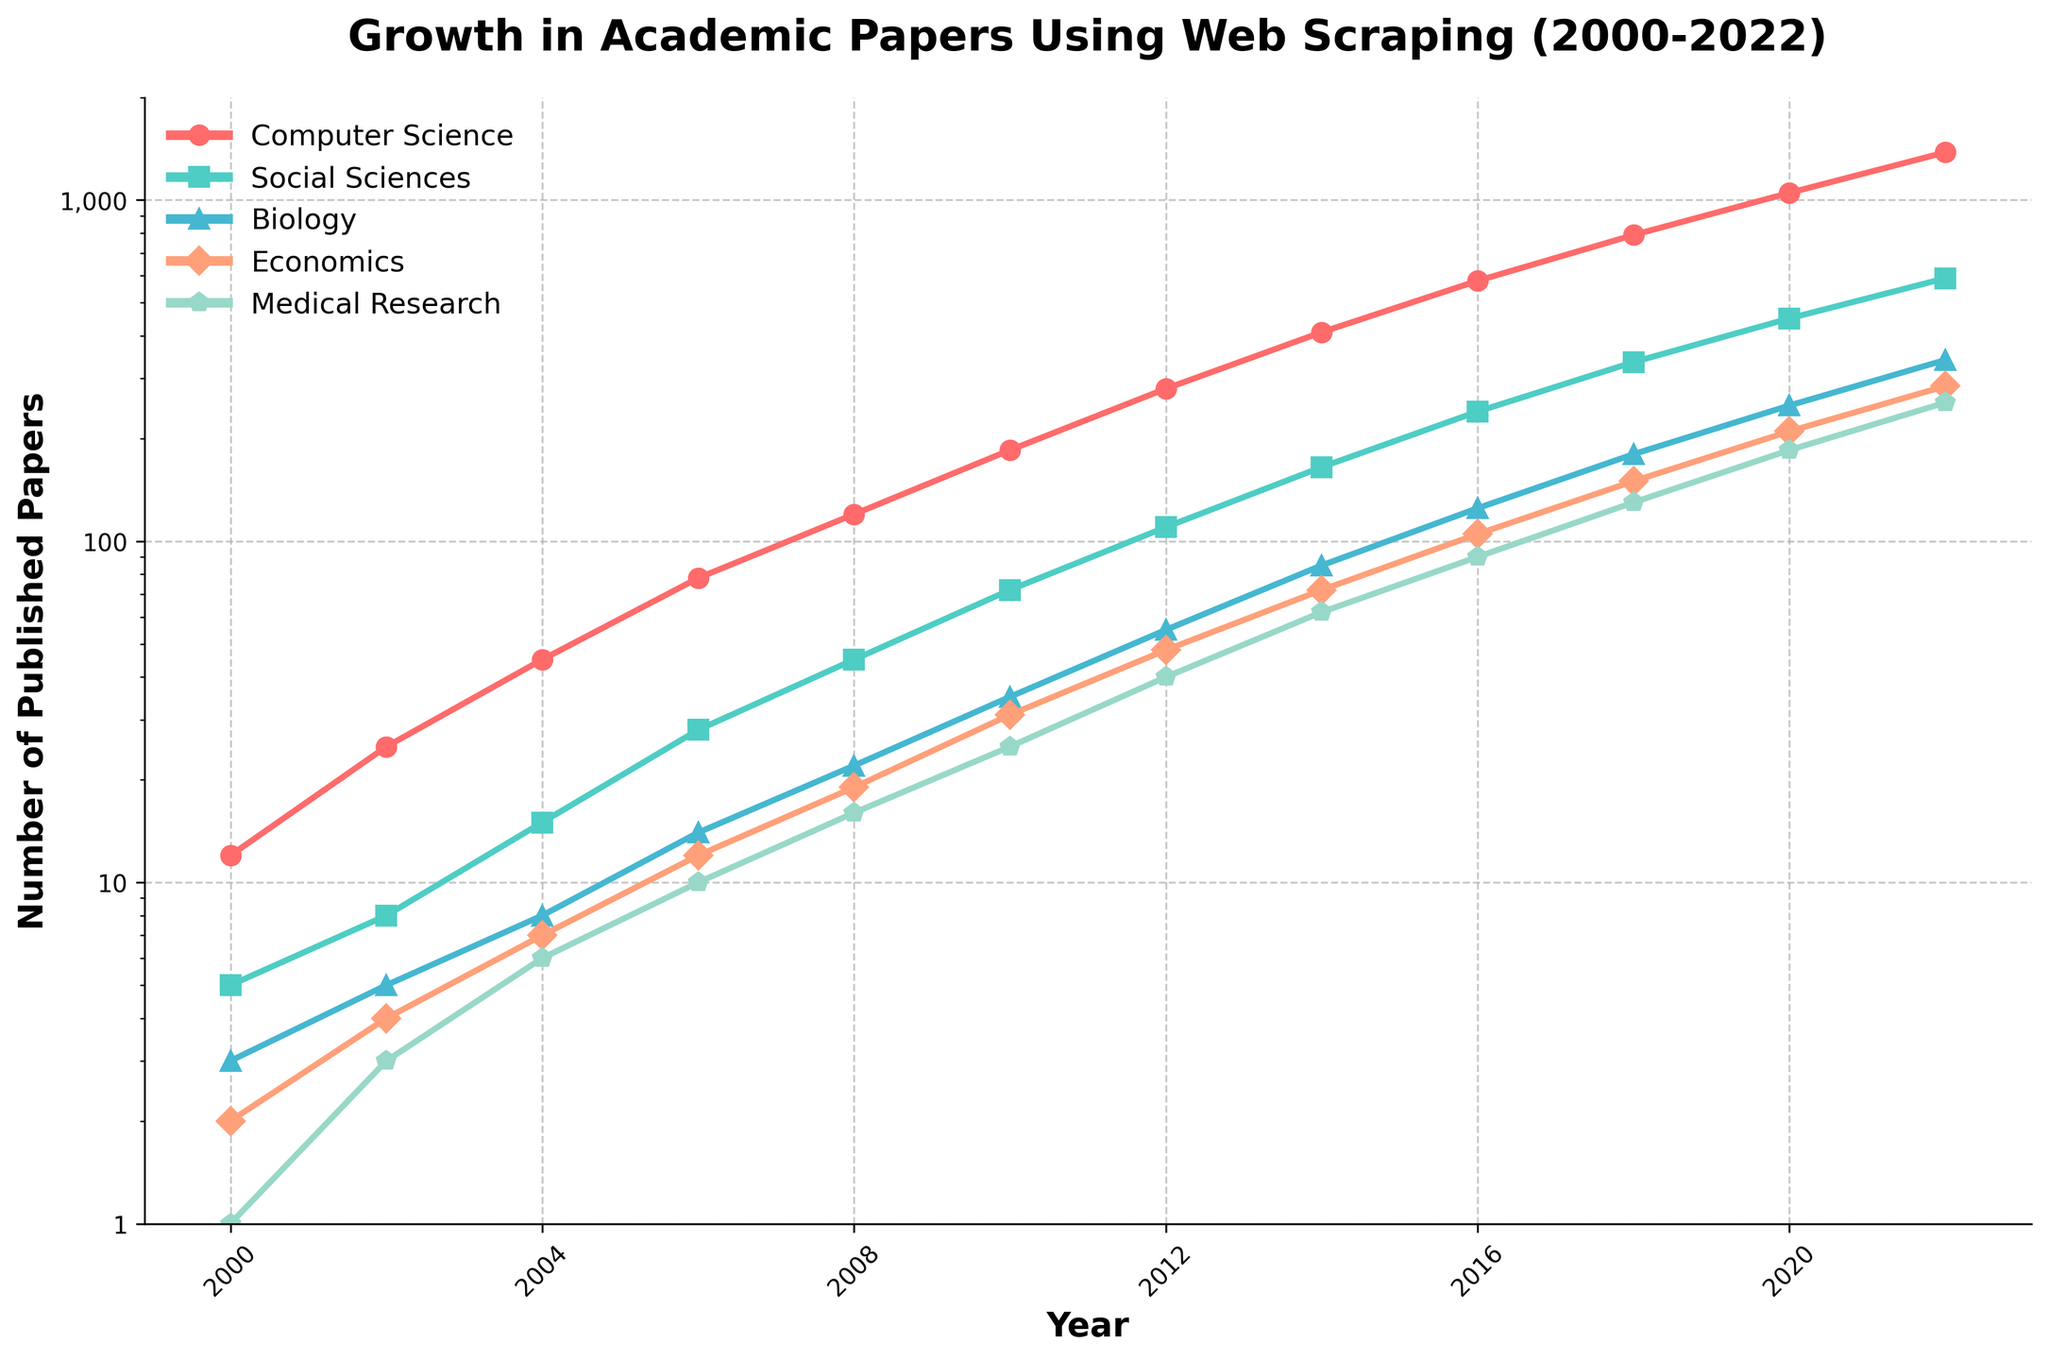What is the overall trend in the number of published papers utilizing web scraping techniques across various research fields since 2000? Starting from 2000, all fields show a consistent upward trend. Computer Science has the steepest increase, followed by Social Sciences, Biology, Economics, and Medical Research.
Answer: Steady increase Which research field had the highest number of papers in 2022, and how many were there? In 2022, Computer Science had the highest number of published papers at 1380.
Answer: Computer Science, 1380 Compare the growth in the number of published papers between Computer Science and Social Sciences from 2000 to 2010. In 2000, Computer Science had 12 papers, and Social Sciences had 5. By 2010, Computer Science had 185 papers, and Social Sciences had 72. The growth for Computer Science is 185 - 12 = 173 papers, and for Social Sciences, it is 72 - 5 = 67 papers.
Answer: Computer Science: 173, Social Sciences: 67 What is the total number of papers published in Biology from 2006 to 2014? Adding the number of published papers from 2006 (14), 2008 (22), 2010 (35), 2012 (55), and 2014 (85) results in 14 + 22 + 35 + 55 + 85 = 211 papers.
Answer: 211 Which year showed the highest publication growth rate for Medical Research, and what is the approximate rate? Comparing year-over-year growth from the available data, the largest jump for Medical Research is from 2016 (90 papers) to 2018 (130 papers), which is approximately a 44% increase ((130-90)/90 ≈ 0.44).
Answer: 2016 to 2018, ~44% Identify the field that showed the smallest increase in the number of publications from 2000 to 2002. The smallest increase is in Medical Research, going from 1 paper to 3 papers, which is an increase of 2 papers.
Answer: Medical Research, 2 By what factor did the number of published papers in Computer Science increase from 2000 to 2022? In 2000, there were 12 papers, and in 2022, there were 1380 papers. The factor increase is 1380 / 12 = 115.
Answer: 115 How did the number of publications in Economics change between 2018 and 2022, and was this change larger than that in Biology during the same period? Economics publications increased from 150 in 2018 to 285 in 2022, a change of 135 publications. Biology publications increased from 180 to 340, a change of 160 publications.
Answer: Economics: 135, Biology: 160 In which year did Social Sciences surpass 100 published papers, and what was the exact number? Social Sciences surpassed 100 published papers in 2012 with 110 papers.
Answer: 2012, 110 Assess the visual representation: Which field is represented by a green line, and how can you tell? The field of Social Sciences is represented by a green line. This identification is based on the legend, where the Social Sciences color matches the green line in the plot.
Answer: Social Sciences 